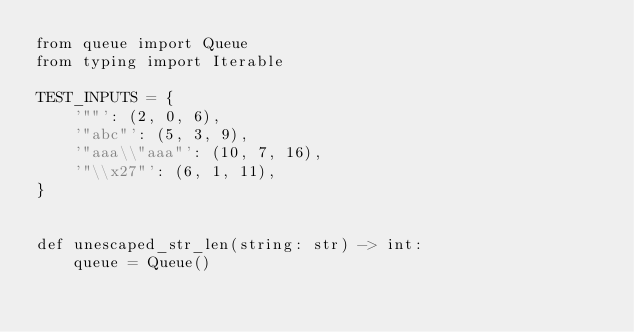Convert code to text. <code><loc_0><loc_0><loc_500><loc_500><_Python_>from queue import Queue
from typing import Iterable

TEST_INPUTS = {
    '""': (2, 0, 6),
    '"abc"': (5, 3, 9),
    '"aaa\\"aaa"': (10, 7, 16),
    '"\\x27"': (6, 1, 11),
}


def unescaped_str_len(string: str) -> int:
    queue = Queue()</code> 